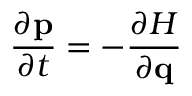Convert formula to latex. <formula><loc_0><loc_0><loc_500><loc_500>{ \frac { \partial p } { \partial t } } = - { \frac { \partial H } { \partial q } }</formula> 